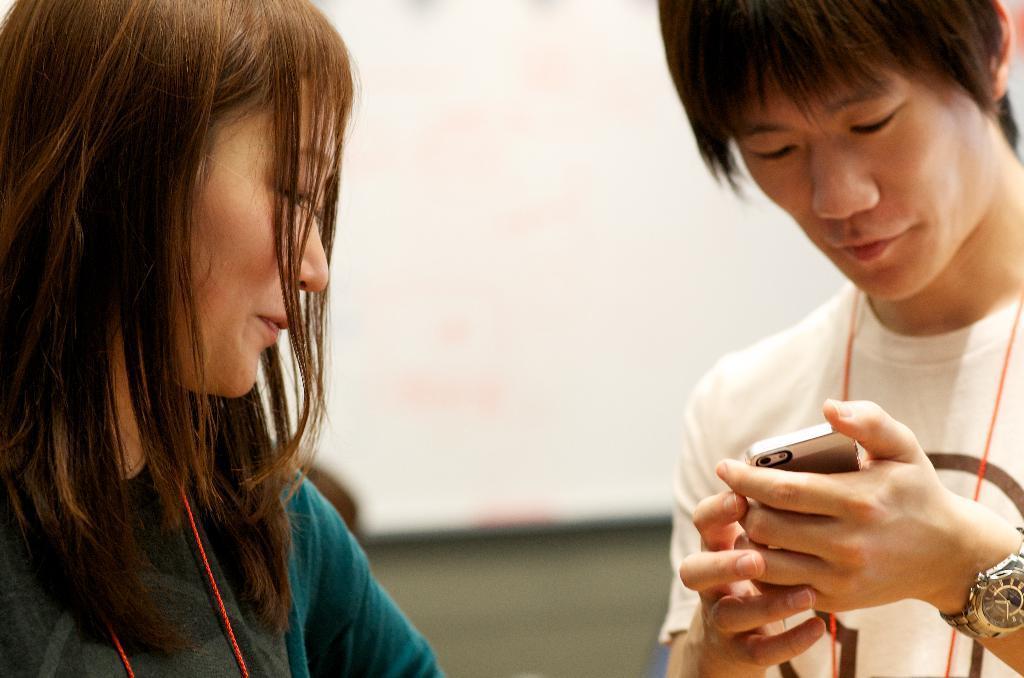Can you describe this image briefly? In this image on the right side there is one man who is holding a phone and looking at phone and he is wearing a watch. On the left side there is one woman, on the background there is a wall. 